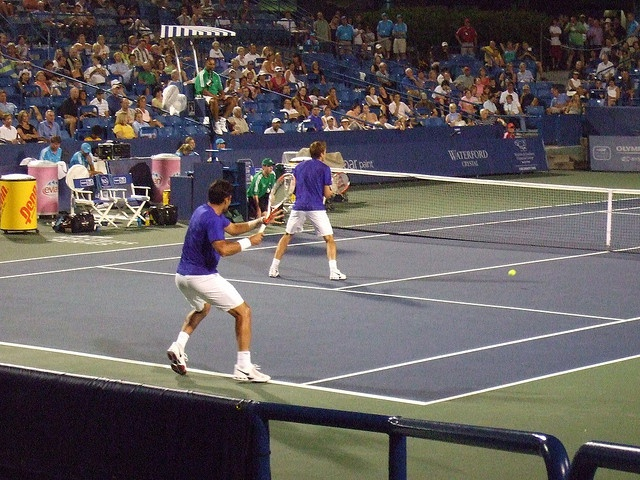Describe the objects in this image and their specific colors. I can see people in maroon, black, and gray tones, people in maroon, white, black, navy, and gray tones, people in maroon, white, darkblue, navy, and darkgray tones, chair in maroon, ivory, gray, darkgray, and tan tones, and chair in maroon, gray, ivory, darkgray, and black tones in this image. 